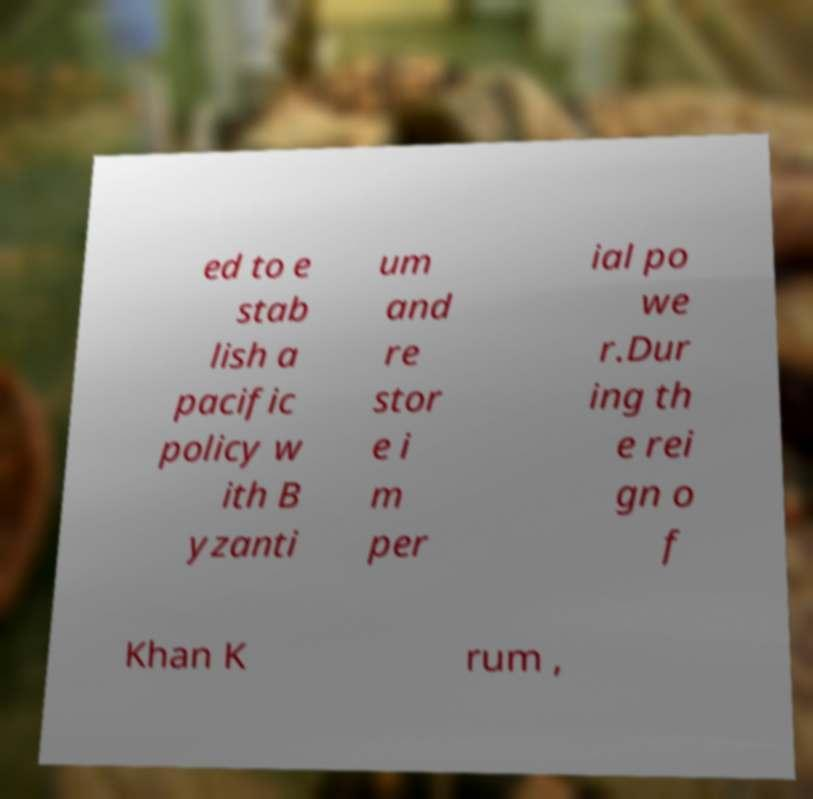Please identify and transcribe the text found in this image. ed to e stab lish a pacific policy w ith B yzanti um and re stor e i m per ial po we r.Dur ing th e rei gn o f Khan K rum , 